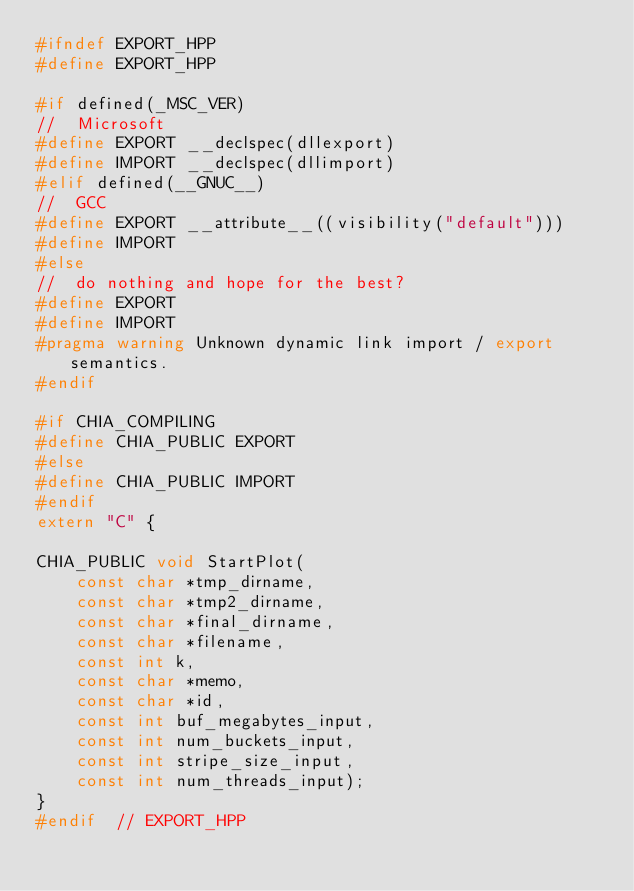<code> <loc_0><loc_0><loc_500><loc_500><_C++_>#ifndef EXPORT_HPP
#define EXPORT_HPP

#if defined(_MSC_VER)
//  Microsoft
#define EXPORT __declspec(dllexport)
#define IMPORT __declspec(dllimport)
#elif defined(__GNUC__)
//  GCC
#define EXPORT __attribute__((visibility("default")))
#define IMPORT
#else
//  do nothing and hope for the best?
#define EXPORT
#define IMPORT
#pragma warning Unknown dynamic link import / export semantics.
#endif

#if CHIA_COMPILING
#define CHIA_PUBLIC EXPORT
#else
#define CHIA_PUBLIC IMPORT
#endif
extern "C" {

CHIA_PUBLIC void StartPlot(
    const char *tmp_dirname,
    const char *tmp2_dirname,
    const char *final_dirname,
    const char *filename,
    const int k,
    const char *memo,
    const char *id,
    const int buf_megabytes_input,
    const int num_buckets_input,
    const int stripe_size_input,
    const int num_threads_input);
}
#endif  // EXPORT_HPP</code> 